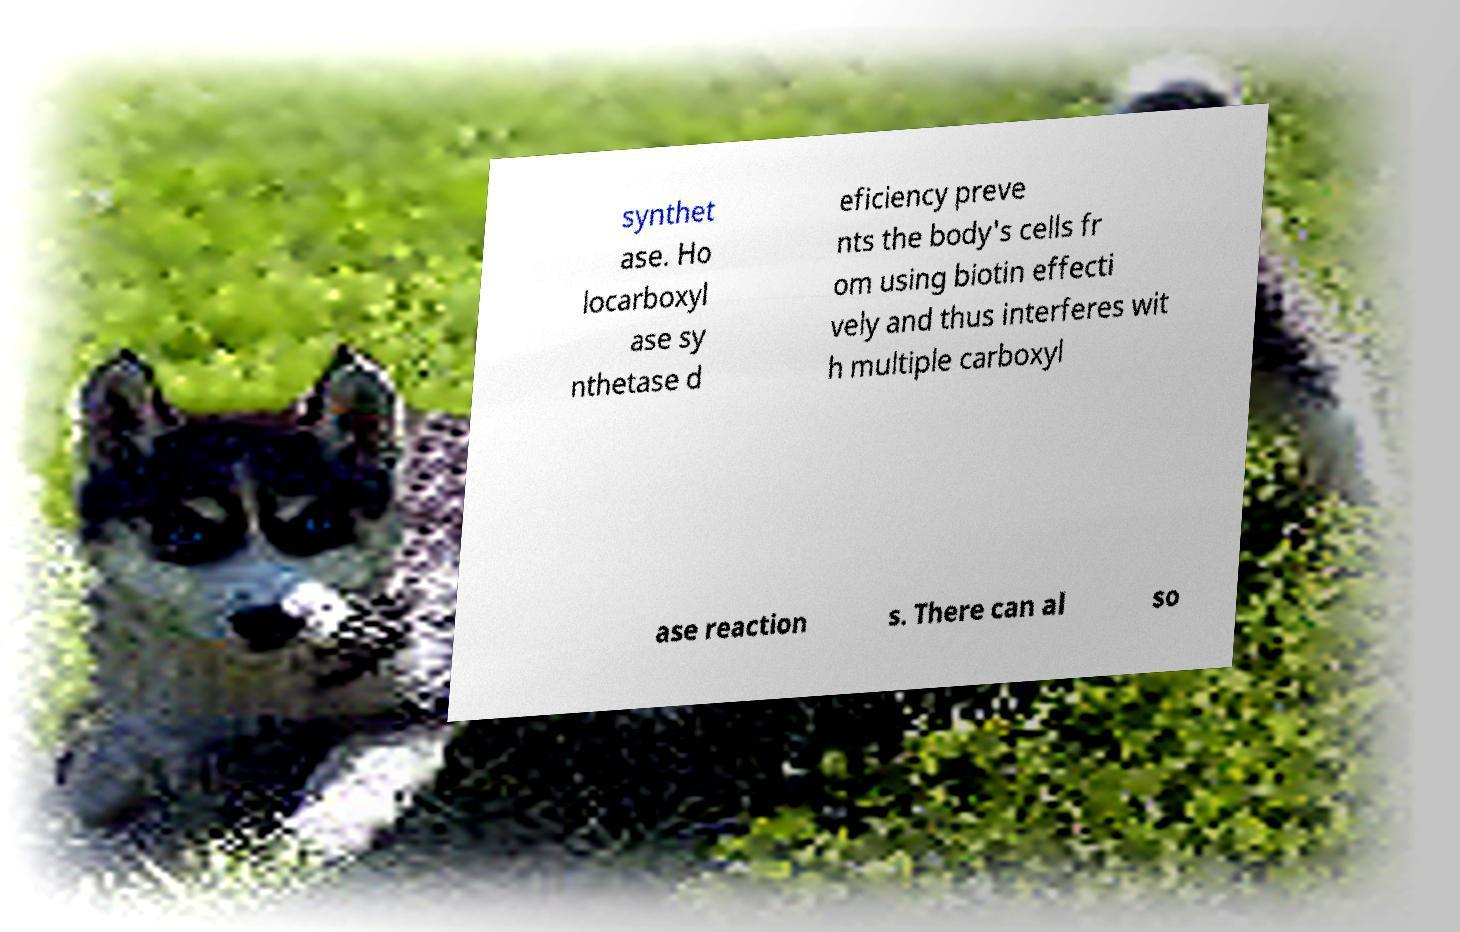For documentation purposes, I need the text within this image transcribed. Could you provide that? synthet ase. Ho locarboxyl ase sy nthetase d eficiency preve nts the body's cells fr om using biotin effecti vely and thus interferes wit h multiple carboxyl ase reaction s. There can al so 